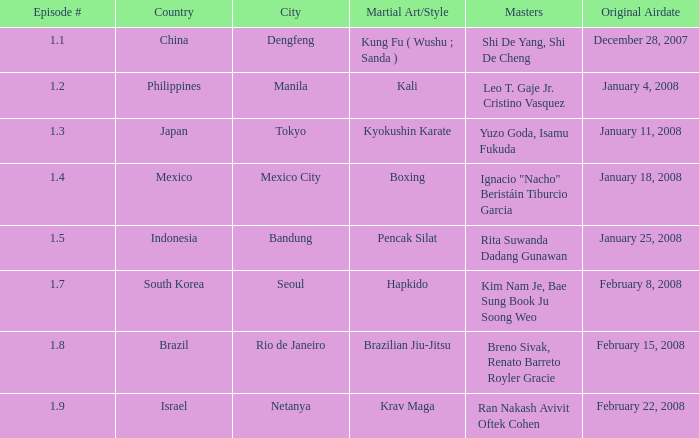8 broadcasted? 1.0. 